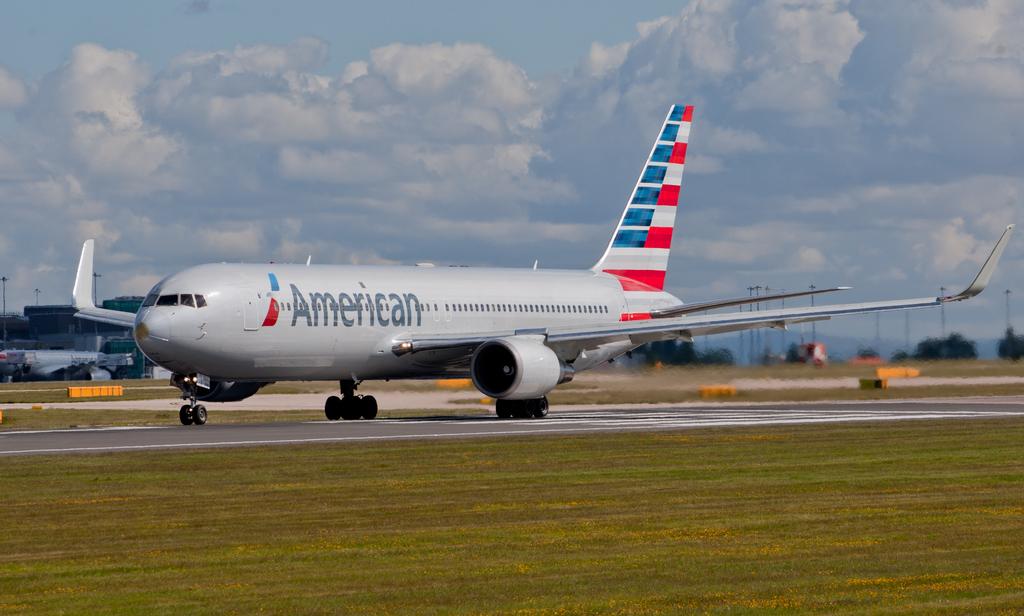What nationality is on the airplane?
Your answer should be compact. American. 